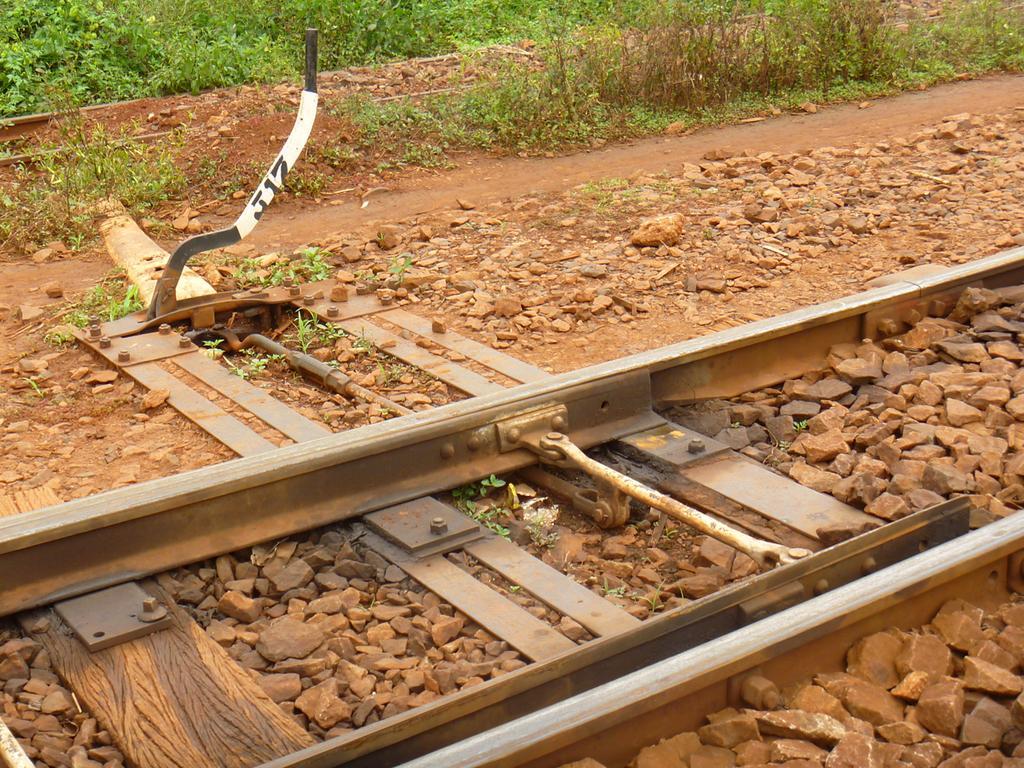Please provide a concise description of this image. In this image we can see railway track, stones, ground, grass and plants. 